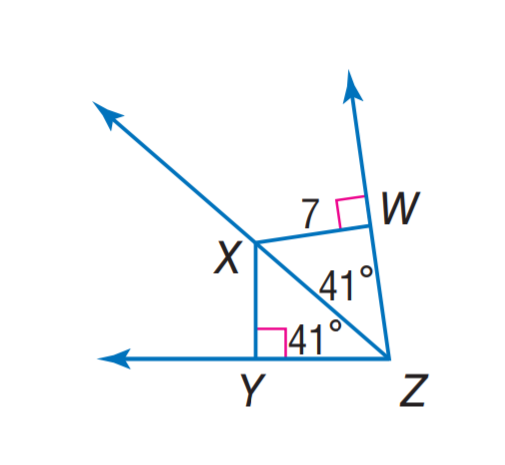Answer the mathemtical geometry problem and directly provide the correct option letter.
Question: Find X Y.
Choices: A: 3.5 B: 7 C: 34 D: 41 B 